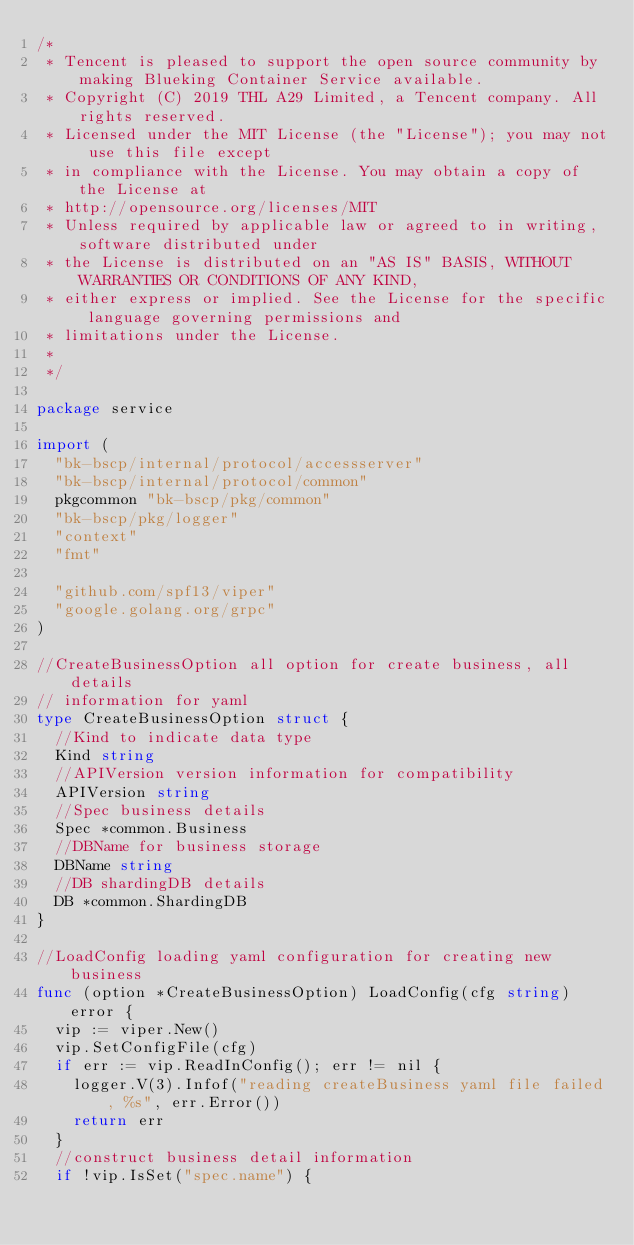Convert code to text. <code><loc_0><loc_0><loc_500><loc_500><_Go_>/*
 * Tencent is pleased to support the open source community by making Blueking Container Service available.
 * Copyright (C) 2019 THL A29 Limited, a Tencent company. All rights reserved.
 * Licensed under the MIT License (the "License"); you may not use this file except
 * in compliance with the License. You may obtain a copy of the License at
 * http://opensource.org/licenses/MIT
 * Unless required by applicable law or agreed to in writing, software distributed under
 * the License is distributed on an "AS IS" BASIS, WITHOUT WARRANTIES OR CONDITIONS OF ANY KIND,
 * either express or implied. See the License for the specific language governing permissions and
 * limitations under the License.
 *
 */

package service

import (
	"bk-bscp/internal/protocol/accessserver"
	"bk-bscp/internal/protocol/common"
	pkgcommon "bk-bscp/pkg/common"
	"bk-bscp/pkg/logger"
	"context"
	"fmt"

	"github.com/spf13/viper"
	"google.golang.org/grpc"
)

//CreateBusinessOption all option for create business, all details
// information for yaml
type CreateBusinessOption struct {
	//Kind to indicate data type
	Kind string
	//APIVersion version information for compatibility
	APIVersion string
	//Spec business details
	Spec *common.Business
	//DBName for business storage
	DBName string
	//DB shardingDB details
	DB *common.ShardingDB
}

//LoadConfig loading yaml configuration for creating new business
func (option *CreateBusinessOption) LoadConfig(cfg string) error {
	vip := viper.New()
	vip.SetConfigFile(cfg)
	if err := vip.ReadInConfig(); err != nil {
		logger.V(3).Infof("reading createBusiness yaml file failed, %s", err.Error())
		return err
	}
	//construct business detail information
	if !vip.IsSet("spec.name") {</code> 